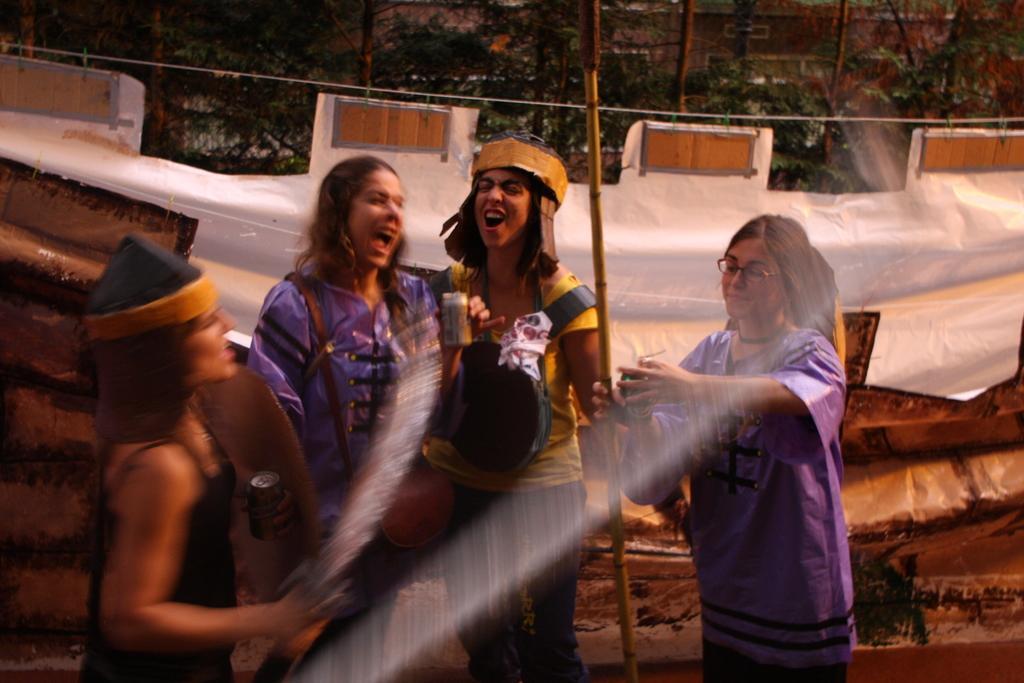How would you summarize this image in a sentence or two? In this picture we can see few women, in the background we can find few trees and a cable, and also we can see water. 